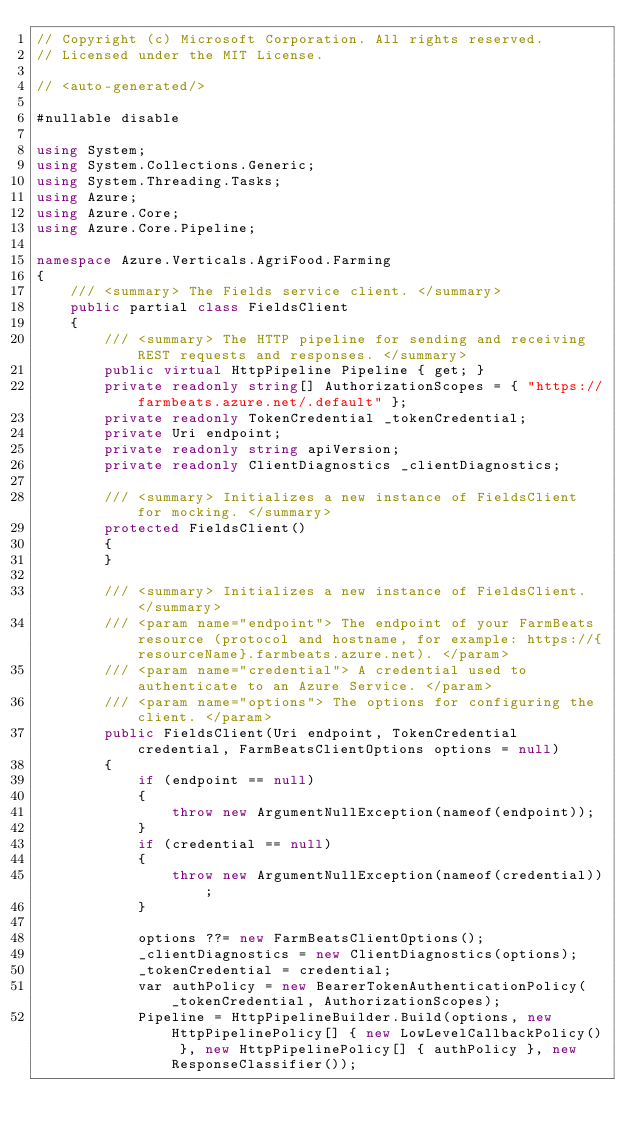Convert code to text. <code><loc_0><loc_0><loc_500><loc_500><_C#_>// Copyright (c) Microsoft Corporation. All rights reserved.
// Licensed under the MIT License.

// <auto-generated/>

#nullable disable

using System;
using System.Collections.Generic;
using System.Threading.Tasks;
using Azure;
using Azure.Core;
using Azure.Core.Pipeline;

namespace Azure.Verticals.AgriFood.Farming
{
    /// <summary> The Fields service client. </summary>
    public partial class FieldsClient
    {
        /// <summary> The HTTP pipeline for sending and receiving REST requests and responses. </summary>
        public virtual HttpPipeline Pipeline { get; }
        private readonly string[] AuthorizationScopes = { "https://farmbeats.azure.net/.default" };
        private readonly TokenCredential _tokenCredential;
        private Uri endpoint;
        private readonly string apiVersion;
        private readonly ClientDiagnostics _clientDiagnostics;

        /// <summary> Initializes a new instance of FieldsClient for mocking. </summary>
        protected FieldsClient()
        {
        }

        /// <summary> Initializes a new instance of FieldsClient. </summary>
        /// <param name="endpoint"> The endpoint of your FarmBeats resource (protocol and hostname, for example: https://{resourceName}.farmbeats.azure.net). </param>
        /// <param name="credential"> A credential used to authenticate to an Azure Service. </param>
        /// <param name="options"> The options for configuring the client. </param>
        public FieldsClient(Uri endpoint, TokenCredential credential, FarmBeatsClientOptions options = null)
        {
            if (endpoint == null)
            {
                throw new ArgumentNullException(nameof(endpoint));
            }
            if (credential == null)
            {
                throw new ArgumentNullException(nameof(credential));
            }

            options ??= new FarmBeatsClientOptions();
            _clientDiagnostics = new ClientDiagnostics(options);
            _tokenCredential = credential;
            var authPolicy = new BearerTokenAuthenticationPolicy(_tokenCredential, AuthorizationScopes);
            Pipeline = HttpPipelineBuilder.Build(options, new HttpPipelinePolicy[] { new LowLevelCallbackPolicy() }, new HttpPipelinePolicy[] { authPolicy }, new ResponseClassifier());</code> 